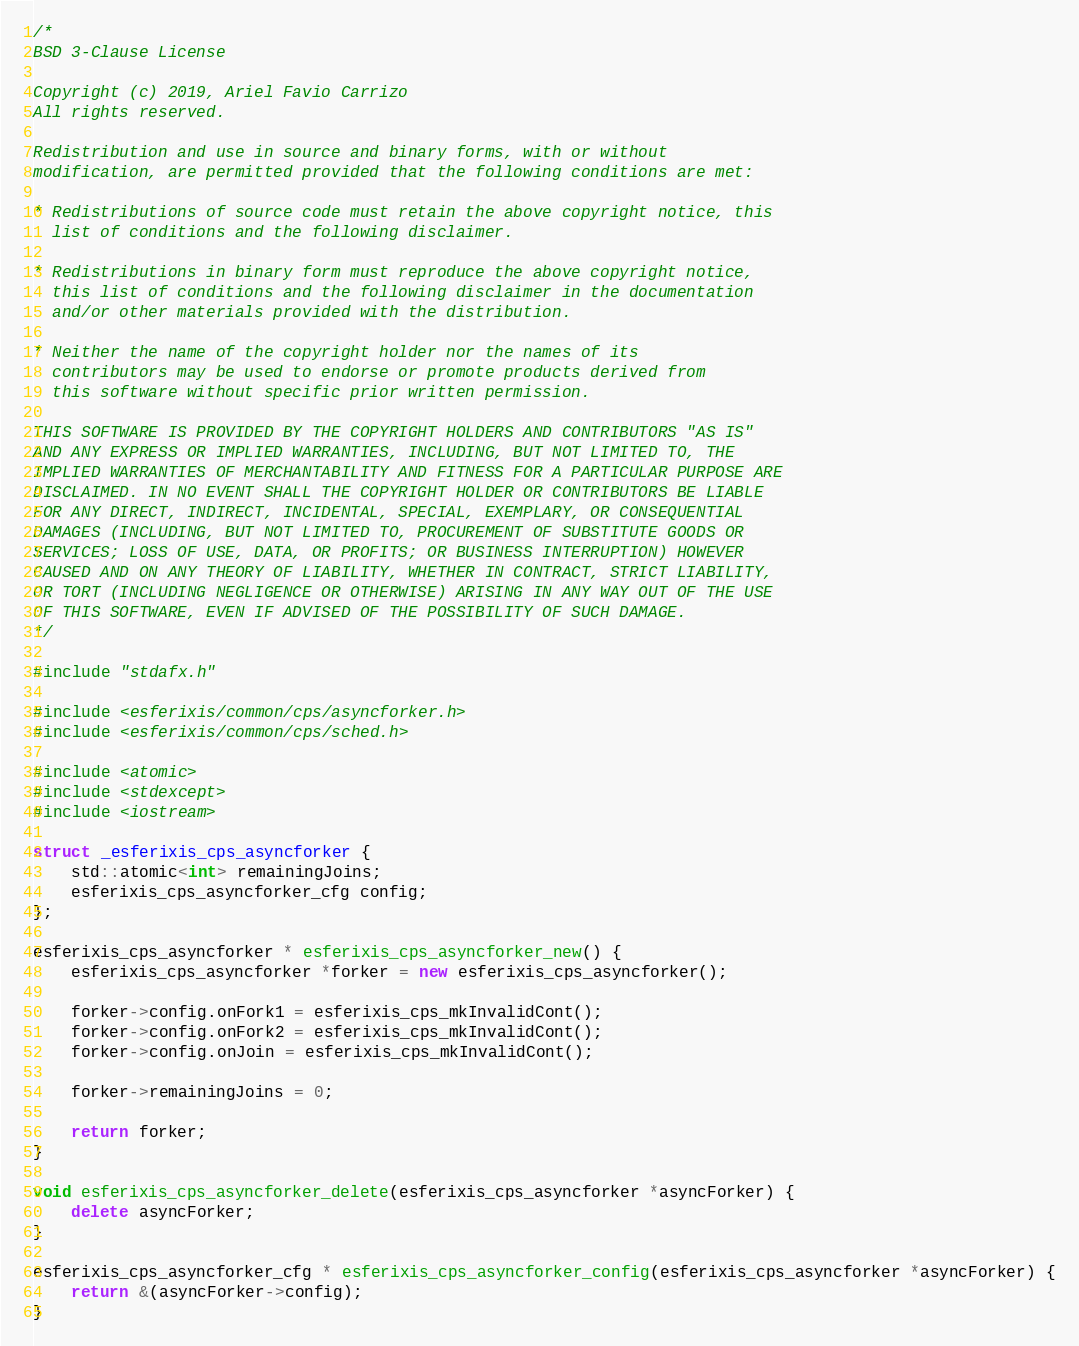Convert code to text. <code><loc_0><loc_0><loc_500><loc_500><_C++_>/*
BSD 3-Clause License

Copyright (c) 2019, Ariel Favio Carrizo
All rights reserved.

Redistribution and use in source and binary forms, with or without
modification, are permitted provided that the following conditions are met:

* Redistributions of source code must retain the above copyright notice, this
  list of conditions and the following disclaimer.

* Redistributions in binary form must reproduce the above copyright notice,
  this list of conditions and the following disclaimer in the documentation
  and/or other materials provided with the distribution.

* Neither the name of the copyright holder nor the names of its
  contributors may be used to endorse or promote products derived from
  this software without specific prior written permission.

THIS SOFTWARE IS PROVIDED BY THE COPYRIGHT HOLDERS AND CONTRIBUTORS "AS IS"
AND ANY EXPRESS OR IMPLIED WARRANTIES, INCLUDING, BUT NOT LIMITED TO, THE
IMPLIED WARRANTIES OF MERCHANTABILITY AND FITNESS FOR A PARTICULAR PURPOSE ARE
DISCLAIMED. IN NO EVENT SHALL THE COPYRIGHT HOLDER OR CONTRIBUTORS BE LIABLE
FOR ANY DIRECT, INDIRECT, INCIDENTAL, SPECIAL, EXEMPLARY, OR CONSEQUENTIAL
DAMAGES (INCLUDING, BUT NOT LIMITED TO, PROCUREMENT OF SUBSTITUTE GOODS OR
SERVICES; LOSS OF USE, DATA, OR PROFITS; OR BUSINESS INTERRUPTION) HOWEVER
CAUSED AND ON ANY THEORY OF LIABILITY, WHETHER IN CONTRACT, STRICT LIABILITY,
OR TORT (INCLUDING NEGLIGENCE OR OTHERWISE) ARISING IN ANY WAY OUT OF THE USE
OF THIS SOFTWARE, EVEN IF ADVISED OF THE POSSIBILITY OF SUCH DAMAGE.
*/

#include "stdafx.h"

#include <esferixis/common/cps/asyncforker.h>
#include <esferixis/common/cps/sched.h>

#include <atomic>
#include <stdexcept>
#include <iostream>

struct _esferixis_cps_asyncforker {
	std::atomic<int> remainingJoins;
	esferixis_cps_asyncforker_cfg config;
};

esferixis_cps_asyncforker * esferixis_cps_asyncforker_new() {
	esferixis_cps_asyncforker *forker = new esferixis_cps_asyncforker();

	forker->config.onFork1 = esferixis_cps_mkInvalidCont();
	forker->config.onFork2 = esferixis_cps_mkInvalidCont();
	forker->config.onJoin = esferixis_cps_mkInvalidCont();

	forker->remainingJoins = 0;

	return forker;
}

void esferixis_cps_asyncforker_delete(esferixis_cps_asyncforker *asyncForker) {
	delete asyncForker;
}

esferixis_cps_asyncforker_cfg * esferixis_cps_asyncforker_config(esferixis_cps_asyncforker *asyncForker) {
	return &(asyncForker->config);
}
</code> 